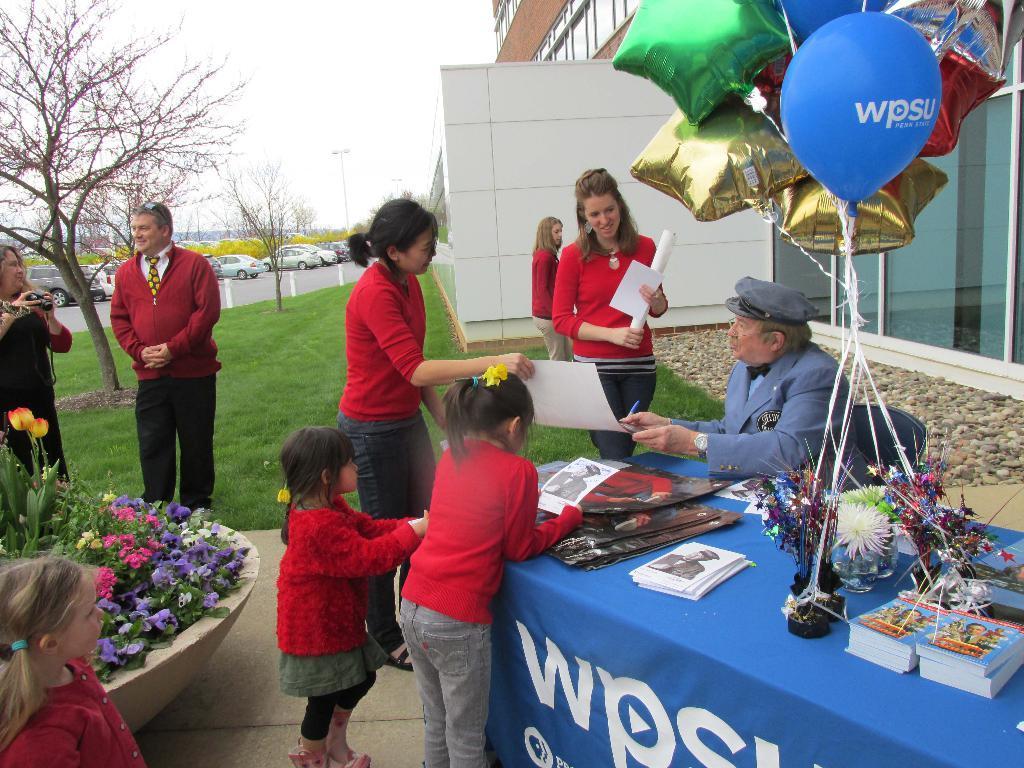Can you describe this image briefly? In this picture there is a table on the right side of the image, on which there are balloons, books and other items, there are people in the center of the image and there is a building at the top side of the image, there are poles, trees, and cars in the background area of the image and there are flowers on the left side of the image. 